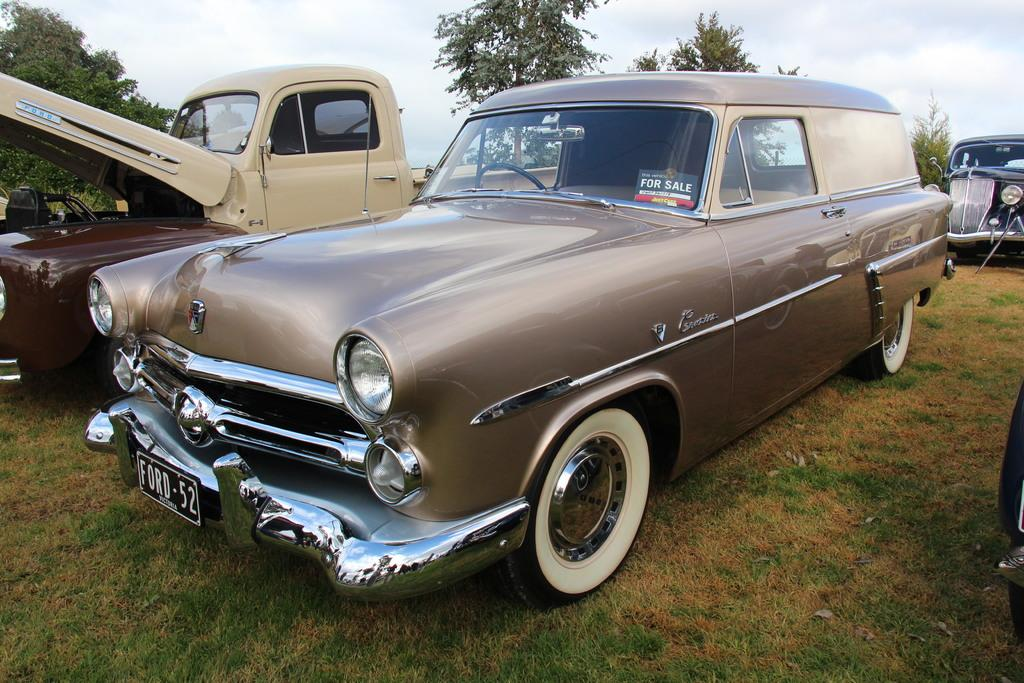<image>
Render a clear and concise summary of the photo. A brown Ford car has a for sale sign in the window. 